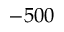Convert formula to latex. <formula><loc_0><loc_0><loc_500><loc_500>- 5 0 0</formula> 